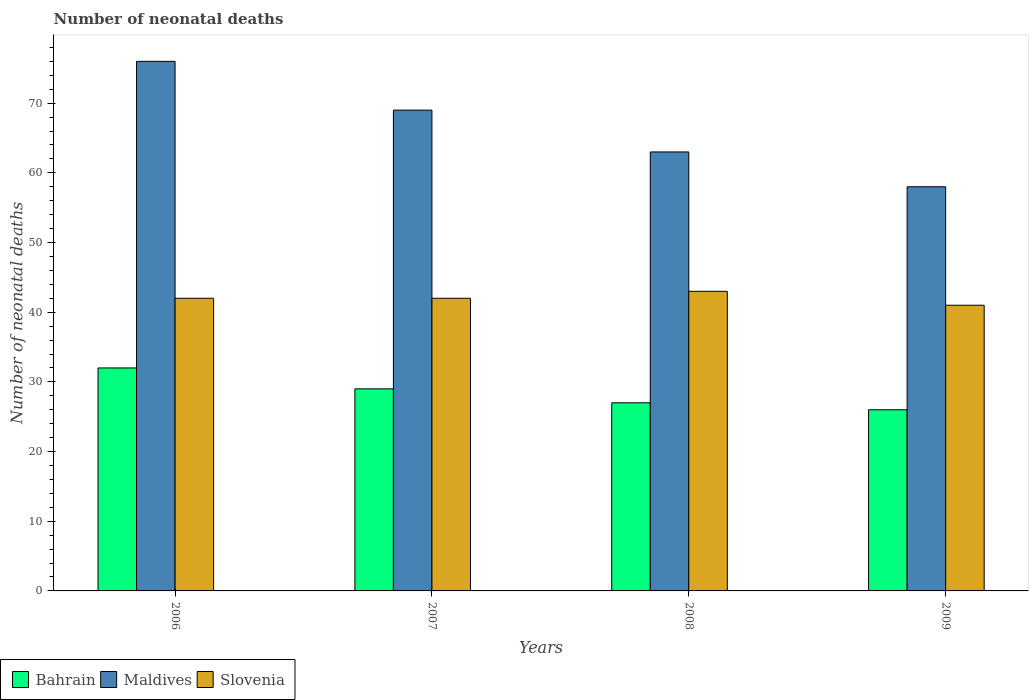Are the number of bars on each tick of the X-axis equal?
Offer a terse response. Yes. How many bars are there on the 4th tick from the right?
Ensure brevity in your answer.  3. What is the number of neonatal deaths in in Slovenia in 2007?
Give a very brief answer. 42. Across all years, what is the maximum number of neonatal deaths in in Slovenia?
Your answer should be very brief. 43. Across all years, what is the minimum number of neonatal deaths in in Bahrain?
Offer a very short reply. 26. What is the total number of neonatal deaths in in Maldives in the graph?
Make the answer very short. 266. What is the difference between the number of neonatal deaths in in Maldives in 2006 and that in 2008?
Your answer should be compact. 13. What is the difference between the number of neonatal deaths in in Bahrain in 2007 and the number of neonatal deaths in in Slovenia in 2006?
Your answer should be very brief. -13. What is the average number of neonatal deaths in in Maldives per year?
Your response must be concise. 66.5. In the year 2007, what is the difference between the number of neonatal deaths in in Maldives and number of neonatal deaths in in Slovenia?
Offer a very short reply. 27. In how many years, is the number of neonatal deaths in in Maldives greater than 20?
Provide a succinct answer. 4. What is the ratio of the number of neonatal deaths in in Maldives in 2007 to that in 2008?
Make the answer very short. 1.1. Is the number of neonatal deaths in in Bahrain in 2006 less than that in 2008?
Give a very brief answer. No. Is the difference between the number of neonatal deaths in in Maldives in 2006 and 2009 greater than the difference between the number of neonatal deaths in in Slovenia in 2006 and 2009?
Your response must be concise. Yes. What is the difference between the highest and the second highest number of neonatal deaths in in Slovenia?
Make the answer very short. 1. What is the difference between the highest and the lowest number of neonatal deaths in in Maldives?
Provide a succinct answer. 18. In how many years, is the number of neonatal deaths in in Maldives greater than the average number of neonatal deaths in in Maldives taken over all years?
Give a very brief answer. 2. Is the sum of the number of neonatal deaths in in Maldives in 2008 and 2009 greater than the maximum number of neonatal deaths in in Bahrain across all years?
Provide a succinct answer. Yes. What does the 1st bar from the left in 2009 represents?
Your answer should be compact. Bahrain. What does the 1st bar from the right in 2007 represents?
Keep it short and to the point. Slovenia. Is it the case that in every year, the sum of the number of neonatal deaths in in Slovenia and number of neonatal deaths in in Maldives is greater than the number of neonatal deaths in in Bahrain?
Your answer should be compact. Yes. Are all the bars in the graph horizontal?
Provide a succinct answer. No. How many years are there in the graph?
Provide a succinct answer. 4. Does the graph contain grids?
Ensure brevity in your answer.  No. Where does the legend appear in the graph?
Keep it short and to the point. Bottom left. What is the title of the graph?
Keep it short and to the point. Number of neonatal deaths. What is the label or title of the Y-axis?
Offer a very short reply. Number of neonatal deaths. What is the Number of neonatal deaths of Maldives in 2006?
Give a very brief answer. 76. What is the Number of neonatal deaths of Bahrain in 2007?
Offer a very short reply. 29. What is the Number of neonatal deaths of Maldives in 2007?
Your answer should be very brief. 69. What is the Number of neonatal deaths in Bahrain in 2008?
Offer a very short reply. 27. What is the Number of neonatal deaths in Maldives in 2008?
Ensure brevity in your answer.  63. What is the Number of neonatal deaths in Slovenia in 2009?
Offer a very short reply. 41. Across all years, what is the maximum Number of neonatal deaths in Maldives?
Keep it short and to the point. 76. Across all years, what is the maximum Number of neonatal deaths in Slovenia?
Your answer should be compact. 43. Across all years, what is the minimum Number of neonatal deaths in Bahrain?
Your answer should be compact. 26. Across all years, what is the minimum Number of neonatal deaths in Slovenia?
Offer a terse response. 41. What is the total Number of neonatal deaths of Bahrain in the graph?
Your answer should be very brief. 114. What is the total Number of neonatal deaths in Maldives in the graph?
Keep it short and to the point. 266. What is the total Number of neonatal deaths of Slovenia in the graph?
Make the answer very short. 168. What is the difference between the Number of neonatal deaths in Slovenia in 2006 and that in 2007?
Your response must be concise. 0. What is the difference between the Number of neonatal deaths of Maldives in 2006 and that in 2008?
Give a very brief answer. 13. What is the difference between the Number of neonatal deaths of Slovenia in 2006 and that in 2008?
Your answer should be compact. -1. What is the difference between the Number of neonatal deaths in Slovenia in 2006 and that in 2009?
Give a very brief answer. 1. What is the difference between the Number of neonatal deaths of Maldives in 2007 and that in 2008?
Keep it short and to the point. 6. What is the difference between the Number of neonatal deaths in Bahrain in 2008 and that in 2009?
Provide a short and direct response. 1. What is the difference between the Number of neonatal deaths of Slovenia in 2008 and that in 2009?
Your response must be concise. 2. What is the difference between the Number of neonatal deaths in Bahrain in 2006 and the Number of neonatal deaths in Maldives in 2007?
Keep it short and to the point. -37. What is the difference between the Number of neonatal deaths in Bahrain in 2006 and the Number of neonatal deaths in Maldives in 2008?
Give a very brief answer. -31. What is the difference between the Number of neonatal deaths of Maldives in 2006 and the Number of neonatal deaths of Slovenia in 2009?
Your answer should be very brief. 35. What is the difference between the Number of neonatal deaths of Bahrain in 2007 and the Number of neonatal deaths of Maldives in 2008?
Keep it short and to the point. -34. What is the difference between the Number of neonatal deaths in Bahrain in 2007 and the Number of neonatal deaths in Slovenia in 2008?
Offer a terse response. -14. What is the difference between the Number of neonatal deaths in Maldives in 2007 and the Number of neonatal deaths in Slovenia in 2008?
Make the answer very short. 26. What is the difference between the Number of neonatal deaths of Bahrain in 2007 and the Number of neonatal deaths of Slovenia in 2009?
Provide a succinct answer. -12. What is the difference between the Number of neonatal deaths of Bahrain in 2008 and the Number of neonatal deaths of Maldives in 2009?
Give a very brief answer. -31. What is the average Number of neonatal deaths in Bahrain per year?
Offer a terse response. 28.5. What is the average Number of neonatal deaths in Maldives per year?
Offer a terse response. 66.5. In the year 2006, what is the difference between the Number of neonatal deaths in Bahrain and Number of neonatal deaths in Maldives?
Your answer should be compact. -44. In the year 2006, what is the difference between the Number of neonatal deaths of Bahrain and Number of neonatal deaths of Slovenia?
Keep it short and to the point. -10. In the year 2007, what is the difference between the Number of neonatal deaths in Bahrain and Number of neonatal deaths in Slovenia?
Keep it short and to the point. -13. In the year 2008, what is the difference between the Number of neonatal deaths in Bahrain and Number of neonatal deaths in Maldives?
Your answer should be compact. -36. In the year 2008, what is the difference between the Number of neonatal deaths in Bahrain and Number of neonatal deaths in Slovenia?
Make the answer very short. -16. In the year 2008, what is the difference between the Number of neonatal deaths in Maldives and Number of neonatal deaths in Slovenia?
Your response must be concise. 20. In the year 2009, what is the difference between the Number of neonatal deaths of Bahrain and Number of neonatal deaths of Maldives?
Keep it short and to the point. -32. In the year 2009, what is the difference between the Number of neonatal deaths of Bahrain and Number of neonatal deaths of Slovenia?
Keep it short and to the point. -15. What is the ratio of the Number of neonatal deaths in Bahrain in 2006 to that in 2007?
Provide a short and direct response. 1.1. What is the ratio of the Number of neonatal deaths in Maldives in 2006 to that in 2007?
Your response must be concise. 1.1. What is the ratio of the Number of neonatal deaths of Slovenia in 2006 to that in 2007?
Provide a short and direct response. 1. What is the ratio of the Number of neonatal deaths of Bahrain in 2006 to that in 2008?
Your answer should be very brief. 1.19. What is the ratio of the Number of neonatal deaths of Maldives in 2006 to that in 2008?
Give a very brief answer. 1.21. What is the ratio of the Number of neonatal deaths in Slovenia in 2006 to that in 2008?
Provide a succinct answer. 0.98. What is the ratio of the Number of neonatal deaths of Bahrain in 2006 to that in 2009?
Keep it short and to the point. 1.23. What is the ratio of the Number of neonatal deaths of Maldives in 2006 to that in 2009?
Your answer should be compact. 1.31. What is the ratio of the Number of neonatal deaths of Slovenia in 2006 to that in 2009?
Give a very brief answer. 1.02. What is the ratio of the Number of neonatal deaths of Bahrain in 2007 to that in 2008?
Your answer should be very brief. 1.07. What is the ratio of the Number of neonatal deaths of Maldives in 2007 to that in 2008?
Offer a terse response. 1.1. What is the ratio of the Number of neonatal deaths of Slovenia in 2007 to that in 2008?
Offer a very short reply. 0.98. What is the ratio of the Number of neonatal deaths in Bahrain in 2007 to that in 2009?
Provide a succinct answer. 1.12. What is the ratio of the Number of neonatal deaths of Maldives in 2007 to that in 2009?
Give a very brief answer. 1.19. What is the ratio of the Number of neonatal deaths of Slovenia in 2007 to that in 2009?
Make the answer very short. 1.02. What is the ratio of the Number of neonatal deaths of Maldives in 2008 to that in 2009?
Your answer should be very brief. 1.09. What is the ratio of the Number of neonatal deaths of Slovenia in 2008 to that in 2009?
Your response must be concise. 1.05. What is the difference between the highest and the second highest Number of neonatal deaths in Bahrain?
Ensure brevity in your answer.  3. What is the difference between the highest and the second highest Number of neonatal deaths of Maldives?
Offer a very short reply. 7. What is the difference between the highest and the second highest Number of neonatal deaths of Slovenia?
Your answer should be compact. 1. What is the difference between the highest and the lowest Number of neonatal deaths of Maldives?
Ensure brevity in your answer.  18. What is the difference between the highest and the lowest Number of neonatal deaths in Slovenia?
Provide a short and direct response. 2. 